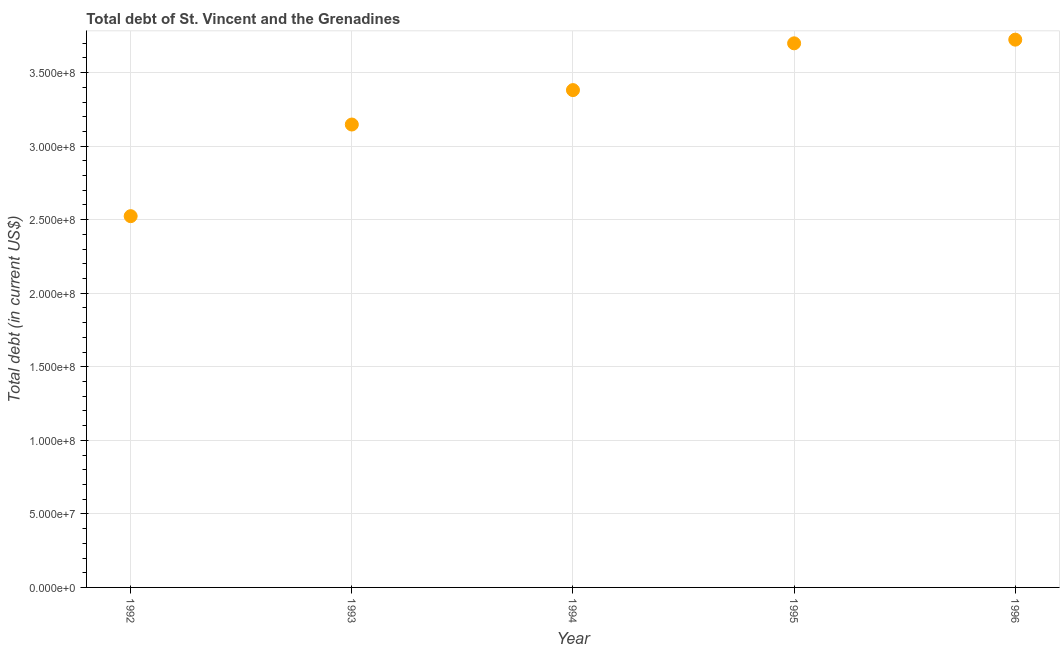What is the total debt in 1994?
Provide a short and direct response. 3.38e+08. Across all years, what is the maximum total debt?
Your response must be concise. 3.72e+08. Across all years, what is the minimum total debt?
Your response must be concise. 2.52e+08. In which year was the total debt minimum?
Provide a short and direct response. 1992. What is the sum of the total debt?
Provide a succinct answer. 1.65e+09. What is the difference between the total debt in 1992 and 1994?
Your answer should be very brief. -8.57e+07. What is the average total debt per year?
Your response must be concise. 3.30e+08. What is the median total debt?
Your answer should be compact. 3.38e+08. In how many years, is the total debt greater than 260000000 US$?
Make the answer very short. 4. Do a majority of the years between 1992 and 1995 (inclusive) have total debt greater than 90000000 US$?
Your answer should be very brief. Yes. What is the ratio of the total debt in 1992 to that in 1993?
Offer a terse response. 0.8. Is the total debt in 1993 less than that in 1995?
Ensure brevity in your answer.  Yes. Is the difference between the total debt in 1992 and 1995 greater than the difference between any two years?
Make the answer very short. No. What is the difference between the highest and the second highest total debt?
Ensure brevity in your answer.  2.50e+06. Is the sum of the total debt in 1995 and 1996 greater than the maximum total debt across all years?
Offer a very short reply. Yes. What is the difference between the highest and the lowest total debt?
Provide a succinct answer. 1.20e+08. How many dotlines are there?
Provide a succinct answer. 1. How many years are there in the graph?
Provide a short and direct response. 5. Does the graph contain any zero values?
Give a very brief answer. No. Does the graph contain grids?
Ensure brevity in your answer.  Yes. What is the title of the graph?
Keep it short and to the point. Total debt of St. Vincent and the Grenadines. What is the label or title of the Y-axis?
Keep it short and to the point. Total debt (in current US$). What is the Total debt (in current US$) in 1992?
Provide a short and direct response. 2.52e+08. What is the Total debt (in current US$) in 1993?
Keep it short and to the point. 3.15e+08. What is the Total debt (in current US$) in 1994?
Offer a very short reply. 3.38e+08. What is the Total debt (in current US$) in 1995?
Ensure brevity in your answer.  3.70e+08. What is the Total debt (in current US$) in 1996?
Keep it short and to the point. 3.72e+08. What is the difference between the Total debt (in current US$) in 1992 and 1993?
Provide a short and direct response. -6.23e+07. What is the difference between the Total debt (in current US$) in 1992 and 1994?
Keep it short and to the point. -8.57e+07. What is the difference between the Total debt (in current US$) in 1992 and 1995?
Offer a very short reply. -1.18e+08. What is the difference between the Total debt (in current US$) in 1992 and 1996?
Keep it short and to the point. -1.20e+08. What is the difference between the Total debt (in current US$) in 1993 and 1994?
Keep it short and to the point. -2.34e+07. What is the difference between the Total debt (in current US$) in 1993 and 1995?
Provide a short and direct response. -5.52e+07. What is the difference between the Total debt (in current US$) in 1993 and 1996?
Your answer should be very brief. -5.77e+07. What is the difference between the Total debt (in current US$) in 1994 and 1995?
Provide a succinct answer. -3.18e+07. What is the difference between the Total debt (in current US$) in 1994 and 1996?
Make the answer very short. -3.43e+07. What is the difference between the Total debt (in current US$) in 1995 and 1996?
Offer a terse response. -2.50e+06. What is the ratio of the Total debt (in current US$) in 1992 to that in 1993?
Provide a succinct answer. 0.8. What is the ratio of the Total debt (in current US$) in 1992 to that in 1994?
Offer a very short reply. 0.75. What is the ratio of the Total debt (in current US$) in 1992 to that in 1995?
Your answer should be very brief. 0.68. What is the ratio of the Total debt (in current US$) in 1992 to that in 1996?
Provide a succinct answer. 0.68. What is the ratio of the Total debt (in current US$) in 1993 to that in 1995?
Ensure brevity in your answer.  0.85. What is the ratio of the Total debt (in current US$) in 1993 to that in 1996?
Offer a very short reply. 0.84. What is the ratio of the Total debt (in current US$) in 1994 to that in 1995?
Offer a terse response. 0.91. What is the ratio of the Total debt (in current US$) in 1994 to that in 1996?
Ensure brevity in your answer.  0.91. 